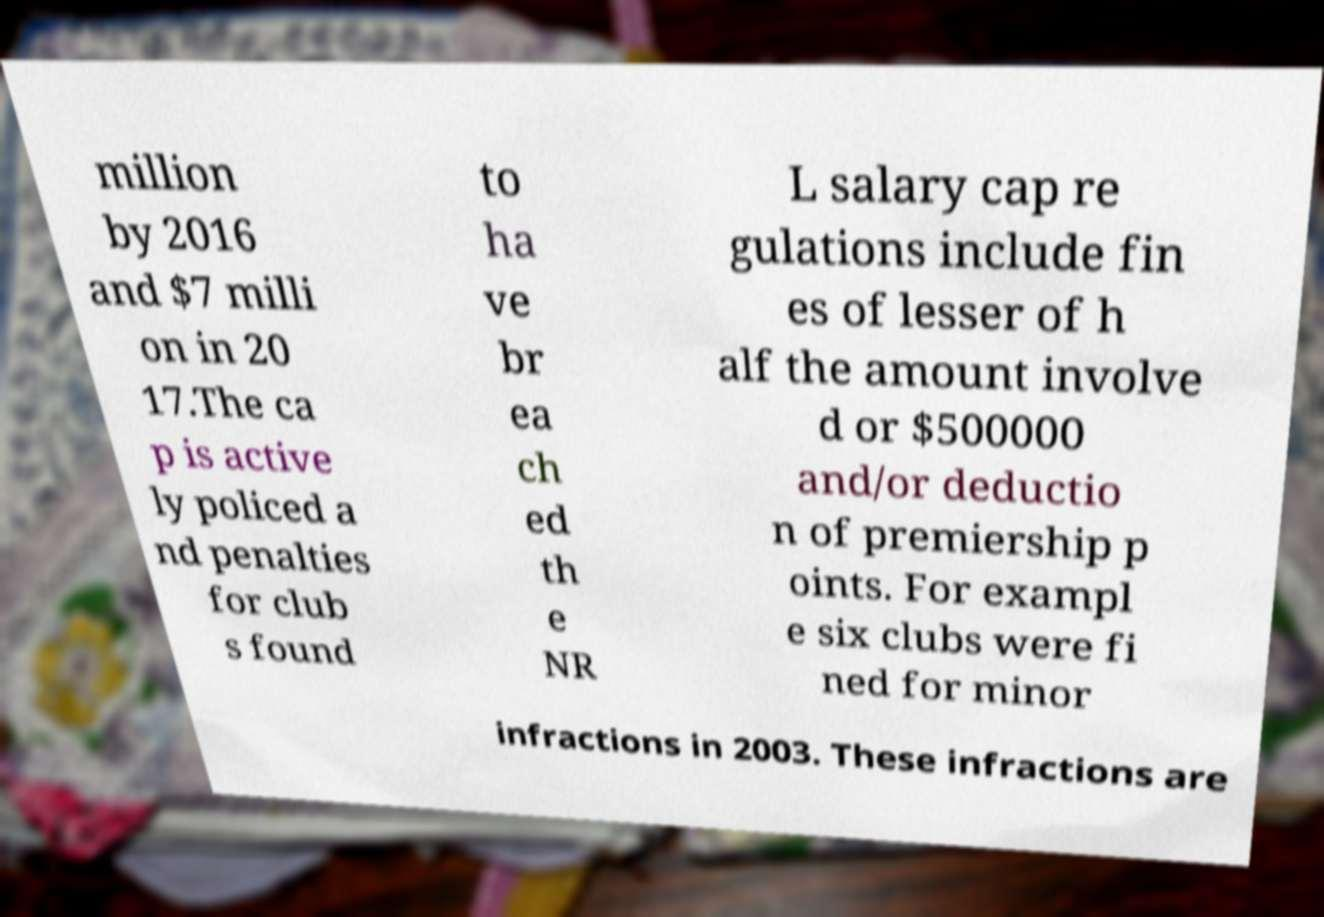Please identify and transcribe the text found in this image. million by 2016 and $7 milli on in 20 17.The ca p is active ly policed a nd penalties for club s found to ha ve br ea ch ed th e NR L salary cap re gulations include fin es of lesser of h alf the amount involve d or $500000 and/or deductio n of premiership p oints. For exampl e six clubs were fi ned for minor infractions in 2003. These infractions are 